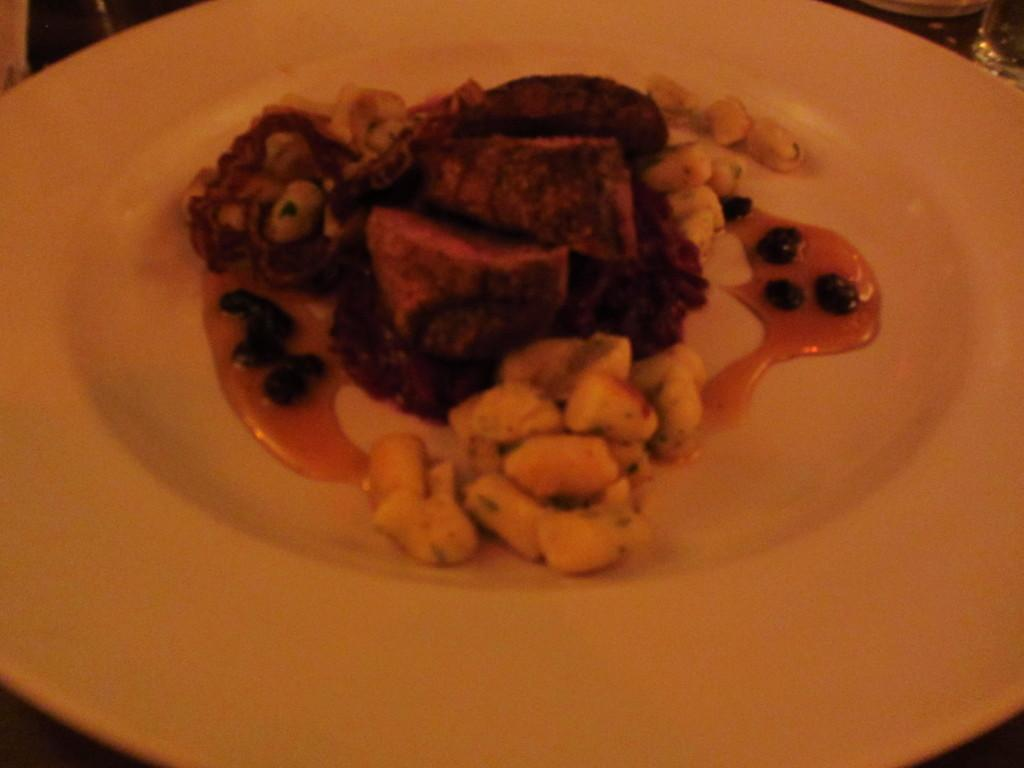What is on the plate that is visible in the image? There is food on a plate in the image. Where are the glasses located in the image? The glasses are in the top right corner of the image. How many letters are visible in the image? There are no letters present in the image. What type of attraction is depicted in the image? There is no attraction depicted in the image; it only shows food on a plate and glasses in the top right corner. 